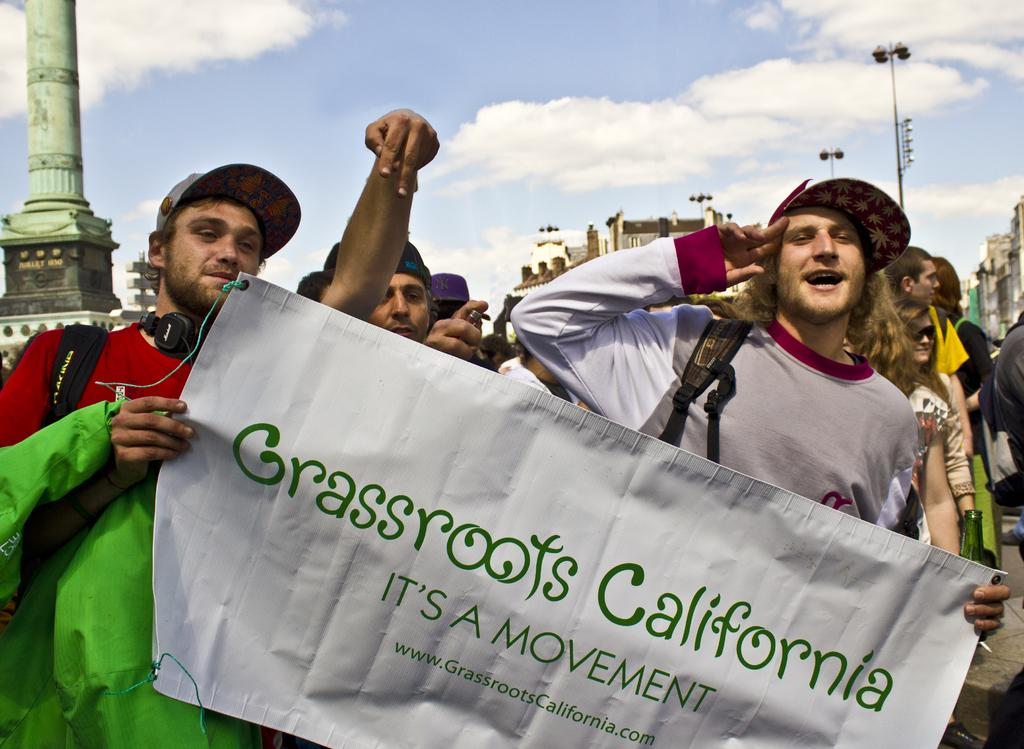What are the two people in the image doing? The two people are holding a banner. What can be seen in the distance behind the people? There are buildings, light poles, and people visible in the background. What is the condition of the sky in the image? Clouds are in the sky. Can you describe any architectural features in the background? Yes, there is a pillar in the background. What type of spark can be seen coming from the banner in the image? There is no spark visible in the image; the two people are simply holding a banner. 